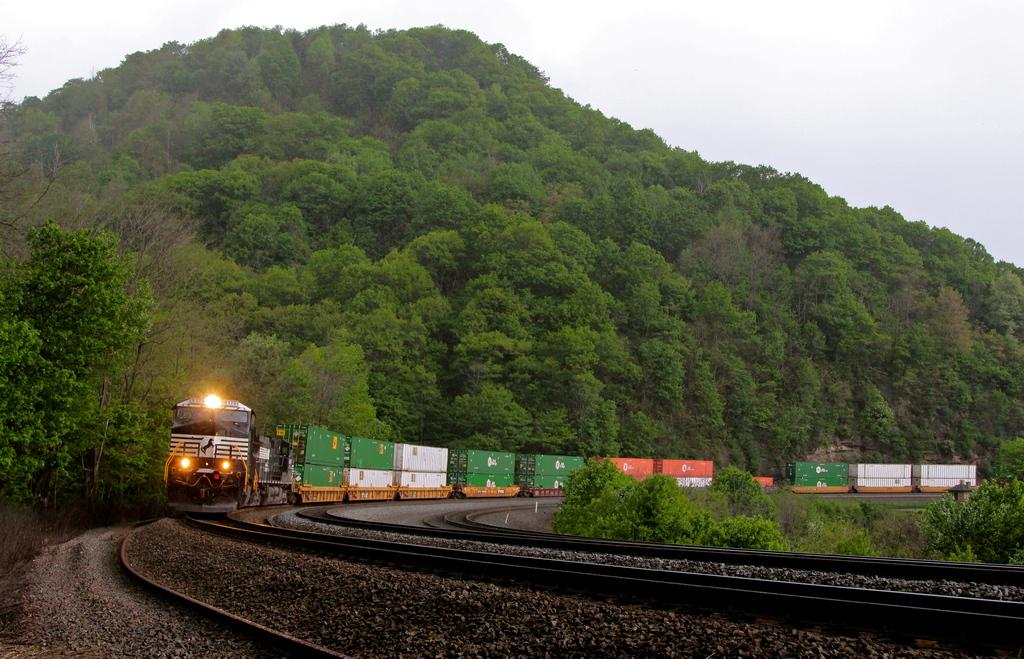What is located in the foreground of the image? There is a railway track in the foreground of the image. What can be seen in the middle of the image? There is a train and trees in the middle of the image. What is visible at the top of the image? The sky is visible at the top of the image. What type of memory is stored in the train in the image? There is no indication of any memory being stored in the train in the image. Can you tell me how many mothers are visible in the image? There are no mothers visible in the image; it features a railway track, a train, trees, and the sky. 